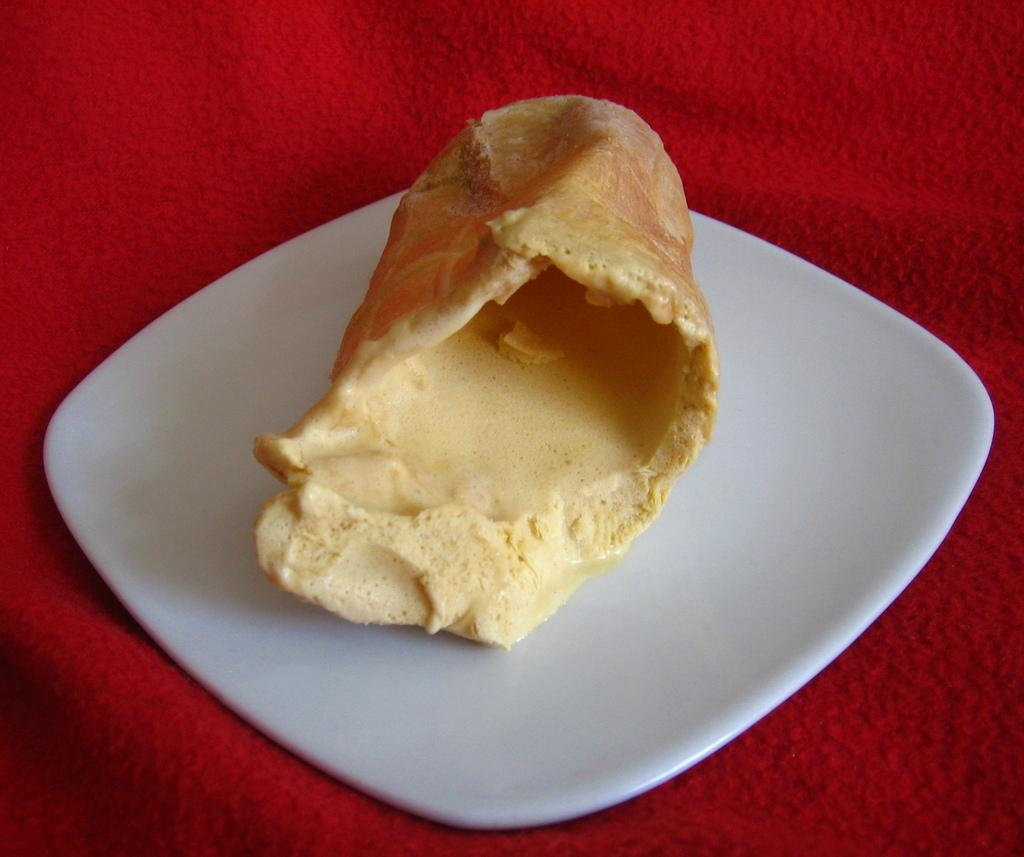What is on the plate that is visible in the image? There is a plate containing food in the image. What type of slope can be seen in the image? There is no slope present in the image; it features a plate containing food. What kind of patch is visible on the plate in the image? There is no patch present on the plate in the image; it contains food. 